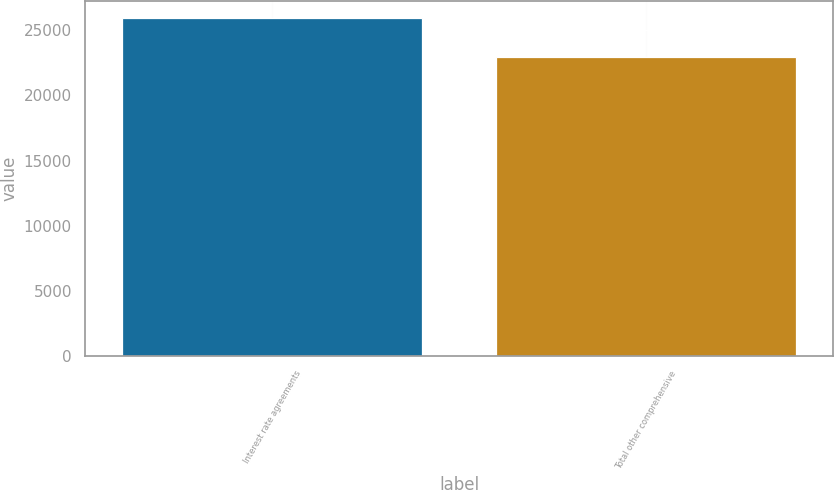Convert chart to OTSL. <chart><loc_0><loc_0><loc_500><loc_500><bar_chart><fcel>Interest rate agreements<fcel>Total other comprehensive<nl><fcel>25966<fcel>22944<nl></chart> 